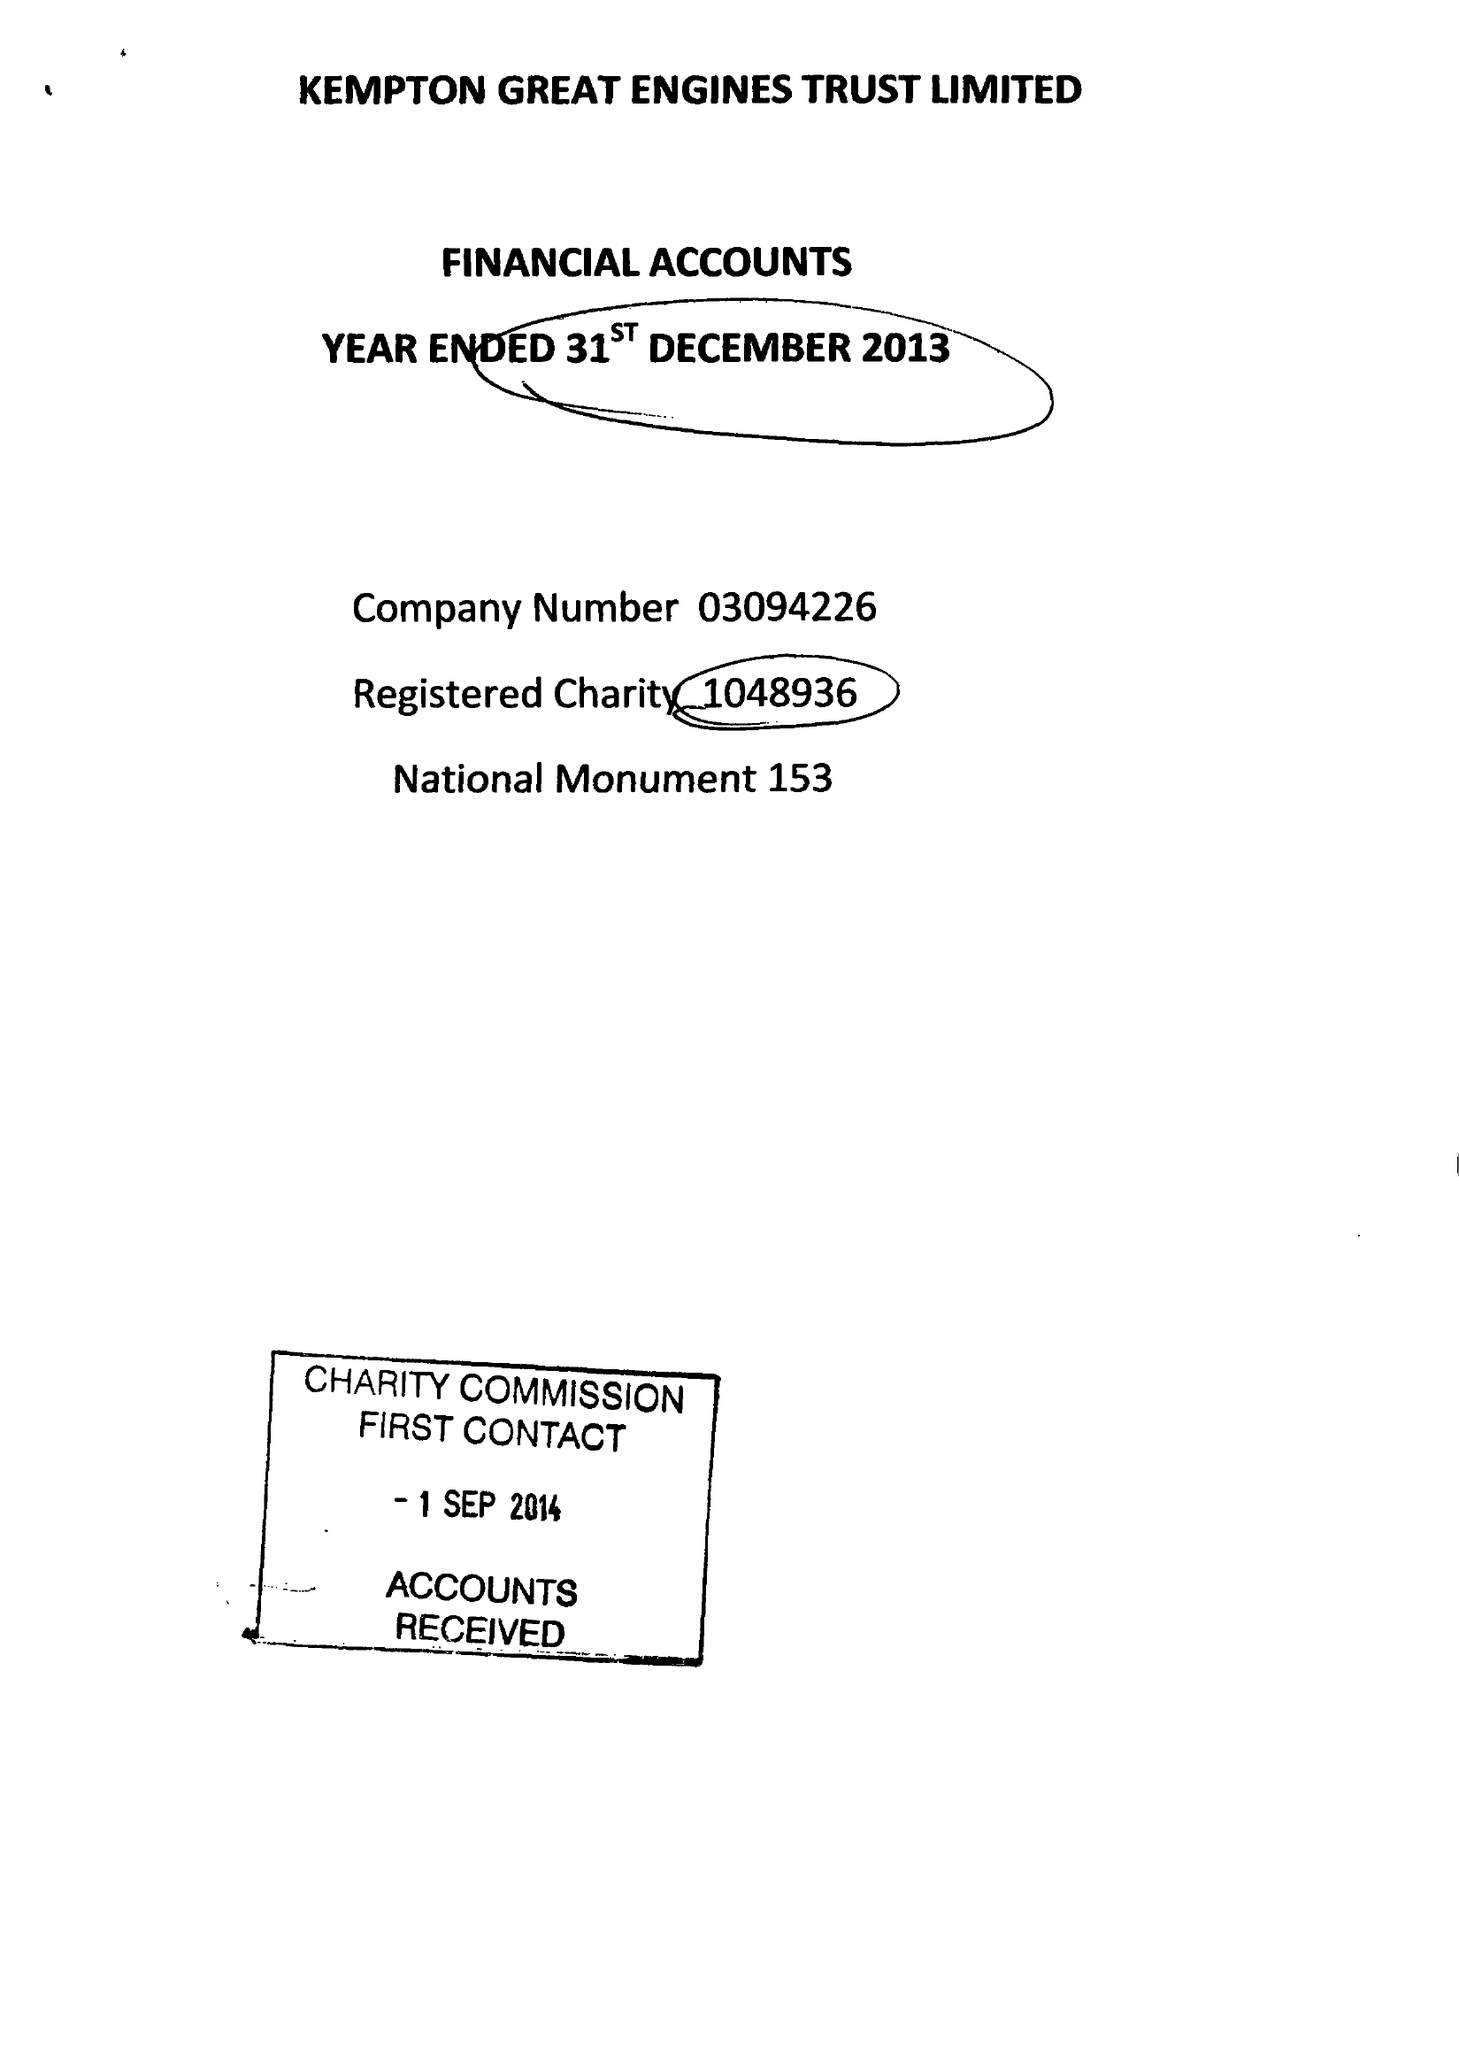What is the value for the address__post_town?
Answer the question using a single word or phrase. FELTHAM 